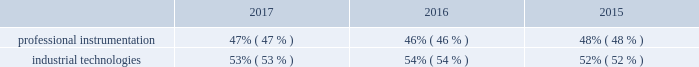The new york stock exchange ( the 201cseparation 201d ) .
The separation was effectuated through a pro-rata dividend distribution on july 2 , 2016 of all of the then-outstanding shares of common stock of fortive corporation to the holders of common stock of danaher as of june 15 , 2016 .
In this annual report , the terms 201cfortive 201d or the 201ccompany 201d refer to either fortive corporation or to fortive corporation and its consolidated subsidiaries , as the context requires .
Reportable segments the table below describes the percentage of sales attributable to each of our two segments over each of the last three years ended december 31 , 2017 .
For additional information regarding sales , operating profit and identifiable assets by segment , please refer to note 17 to the consolidated and combined financial statements included in this annual report. .
Professional instrumentation our professional instrumentation segment offers essential products , software and services used to create actionable intelligence by measuring and monitoring a wide range of physical parameters in industrial applications , including electrical current , radio frequency signals , distance , pressure , temperature , radiation , and hazardous gases .
Customers for these products and services include industrial service , installation and maintenance professionals , designers and manufacturers of electronic devices and instruments , medical technicians , safety professionals and other customers for whom precision , reliability and safety are critical in their specific applications .
2017 sales for this segment by geographic destination were : north america , 50% ( 50 % ) ; europe , 18% ( 18 % ) ; asia pacific , 26% ( 26 % ) , and all other regions , 6% ( 6 % ) .
Our professional instrumentation segment consists of our advanced instrumentation & solutions and sensing technologies businesses .
Our advanced instrumentation & solutions business was primarily established through the acquisitions of qualitrol in the 1980s , fluke corporation in 1998 , pacific scientific company in 1998 , tektronix in 2007 , invetech in 2007 , keithley instruments in 2010 , emaint in 2016 , industrial scientific in 2017 , landauer in 2017 and numerous bolt-on acquisitions .
Advanced instrumentation & solutions our advanced instrumentation & solutions business consists of : field solutions our field solutions products include a variety of compact professional test tools , thermal imaging and calibration equipment for electrical , industrial , electronic and calibration applications , online condition-based monitoring equipment ; portable gas detection equipment , consumables , and software as a service ( saas ) offerings including safety/user behavior , asset management , and compliance monitoring ; subscription-based technical , analytical , and compliance services to determine occupational and environmental radiation exposure ; and computerized maintenance management software for critical infrastructure in utility , industrial , energy , construction , public safety , mining , and healthcare applications .
These products and associated software solutions measure voltage , current , resistance , power quality , frequency , pressure , temperature , radiation , hazardous gas and air quality , among other parameters .
Typical users of these products and software include electrical engineers , electricians , electronic technicians , safety professionals , medical technicians , network technicians , first-responders , and industrial service , installation and maintenance professionals .
The business also makes and sells instruments , controls and monitoring and maintenance systems used by maintenance departments in utilities and industrial facilities to monitor assets , including transformers , generators , motors and switchgear .
Products are marketed under a variety of brands , including fluke , fluke biomedical , fluke networks , industrial scientific , landauer and qualitrol .
Product realization our product realization services and products help developers and engineers across the end-to-end product creation cycle from concepts to finished products .
Our test , measurement and monitoring products are used in the design , manufacturing and development of electronics , industrial , video and other advanced technologies .
Typical users of these products and services include research and development engineers who design , de-bug , monitor and validate the function and performance of electronic components , subassemblies and end-products , and video equipment manufacturers , content developers and broadcasters .
The business also provides a full range of design , engineering and manufacturing services and highly-engineered , modular components to enable conceptualization , development and launch of products in the medical diagnostics , cell therapy and consumer markets .
Finally , the business designs , develops , manufactures and markets critical , highly-engineered energetic materials components in specialized vertical applications .
Products and services are marketed .
What was the change in percentage of sales attributable to professional instrumentation from 2016 to 2017? 
Computations: (47% - 46%)
Answer: 0.01. 